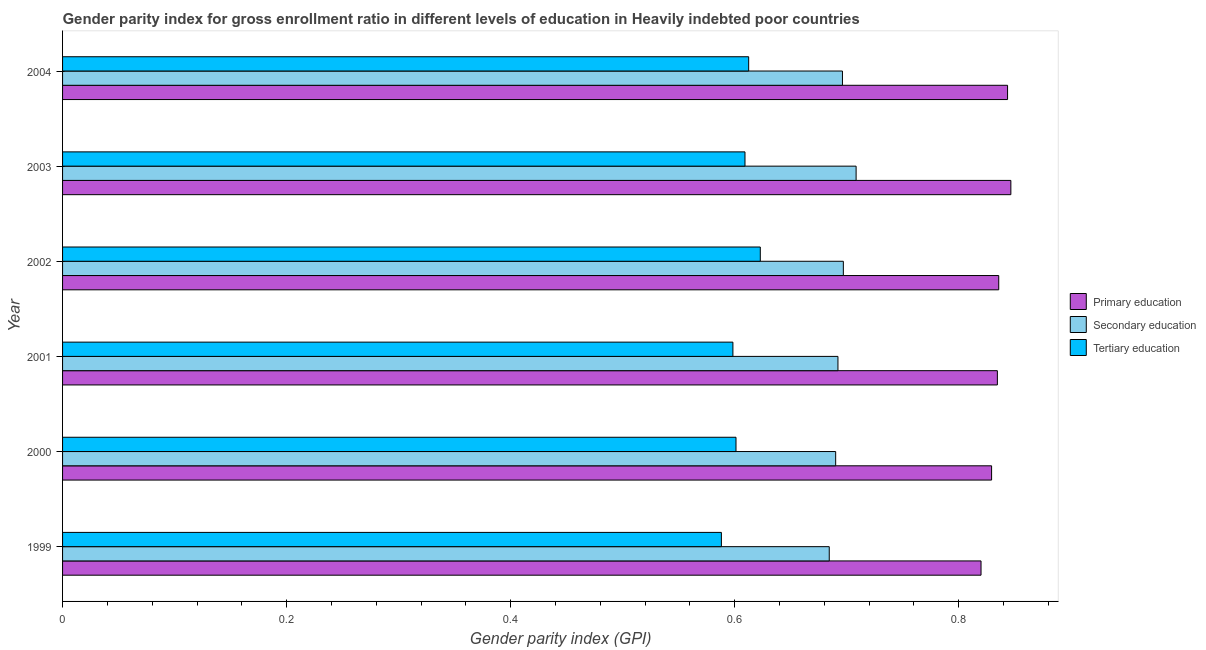How many groups of bars are there?
Offer a terse response. 6. Are the number of bars per tick equal to the number of legend labels?
Make the answer very short. Yes. How many bars are there on the 3rd tick from the bottom?
Provide a succinct answer. 3. What is the label of the 5th group of bars from the top?
Ensure brevity in your answer.  2000. What is the gender parity index in primary education in 2001?
Ensure brevity in your answer.  0.83. Across all years, what is the maximum gender parity index in primary education?
Your answer should be very brief. 0.85. Across all years, what is the minimum gender parity index in secondary education?
Provide a short and direct response. 0.68. In which year was the gender parity index in tertiary education maximum?
Give a very brief answer. 2002. What is the total gender parity index in secondary education in the graph?
Keep it short and to the point. 4.17. What is the difference between the gender parity index in tertiary education in 2000 and that in 2004?
Your response must be concise. -0.01. What is the difference between the gender parity index in tertiary education in 2002 and the gender parity index in primary education in 2003?
Provide a short and direct response. -0.22. What is the average gender parity index in secondary education per year?
Your response must be concise. 0.69. In the year 2003, what is the difference between the gender parity index in primary education and gender parity index in tertiary education?
Your answer should be very brief. 0.24. What is the ratio of the gender parity index in primary education in 2000 to that in 2001?
Your answer should be very brief. 0.99. What does the 2nd bar from the top in 2000 represents?
Your response must be concise. Secondary education. What does the 3rd bar from the bottom in 2001 represents?
Offer a terse response. Tertiary education. Are all the bars in the graph horizontal?
Your response must be concise. Yes. How many years are there in the graph?
Provide a short and direct response. 6. What is the difference between two consecutive major ticks on the X-axis?
Provide a succinct answer. 0.2. Are the values on the major ticks of X-axis written in scientific E-notation?
Ensure brevity in your answer.  No. Where does the legend appear in the graph?
Make the answer very short. Center right. How are the legend labels stacked?
Make the answer very short. Vertical. What is the title of the graph?
Provide a short and direct response. Gender parity index for gross enrollment ratio in different levels of education in Heavily indebted poor countries. What is the label or title of the X-axis?
Your answer should be compact. Gender parity index (GPI). What is the Gender parity index (GPI) of Primary education in 1999?
Provide a succinct answer. 0.82. What is the Gender parity index (GPI) in Secondary education in 1999?
Offer a terse response. 0.68. What is the Gender parity index (GPI) of Tertiary education in 1999?
Your answer should be compact. 0.59. What is the Gender parity index (GPI) in Primary education in 2000?
Give a very brief answer. 0.83. What is the Gender parity index (GPI) in Secondary education in 2000?
Your answer should be very brief. 0.69. What is the Gender parity index (GPI) of Tertiary education in 2000?
Make the answer very short. 0.6. What is the Gender parity index (GPI) in Primary education in 2001?
Provide a succinct answer. 0.83. What is the Gender parity index (GPI) in Secondary education in 2001?
Provide a short and direct response. 0.69. What is the Gender parity index (GPI) of Tertiary education in 2001?
Your answer should be compact. 0.6. What is the Gender parity index (GPI) in Primary education in 2002?
Your answer should be very brief. 0.84. What is the Gender parity index (GPI) in Secondary education in 2002?
Your answer should be compact. 0.7. What is the Gender parity index (GPI) in Tertiary education in 2002?
Your response must be concise. 0.62. What is the Gender parity index (GPI) of Primary education in 2003?
Your answer should be compact. 0.85. What is the Gender parity index (GPI) of Secondary education in 2003?
Provide a short and direct response. 0.71. What is the Gender parity index (GPI) in Tertiary education in 2003?
Keep it short and to the point. 0.61. What is the Gender parity index (GPI) of Primary education in 2004?
Your answer should be compact. 0.84. What is the Gender parity index (GPI) in Secondary education in 2004?
Your answer should be compact. 0.7. What is the Gender parity index (GPI) in Tertiary education in 2004?
Your answer should be compact. 0.61. Across all years, what is the maximum Gender parity index (GPI) of Primary education?
Your response must be concise. 0.85. Across all years, what is the maximum Gender parity index (GPI) in Secondary education?
Keep it short and to the point. 0.71. Across all years, what is the maximum Gender parity index (GPI) of Tertiary education?
Provide a succinct answer. 0.62. Across all years, what is the minimum Gender parity index (GPI) in Primary education?
Ensure brevity in your answer.  0.82. Across all years, what is the minimum Gender parity index (GPI) in Secondary education?
Provide a succinct answer. 0.68. Across all years, what is the minimum Gender parity index (GPI) of Tertiary education?
Provide a succinct answer. 0.59. What is the total Gender parity index (GPI) of Primary education in the graph?
Your answer should be very brief. 5.01. What is the total Gender parity index (GPI) in Secondary education in the graph?
Keep it short and to the point. 4.17. What is the total Gender parity index (GPI) of Tertiary education in the graph?
Your answer should be very brief. 3.63. What is the difference between the Gender parity index (GPI) of Primary education in 1999 and that in 2000?
Your answer should be compact. -0.01. What is the difference between the Gender parity index (GPI) in Secondary education in 1999 and that in 2000?
Offer a very short reply. -0.01. What is the difference between the Gender parity index (GPI) of Tertiary education in 1999 and that in 2000?
Keep it short and to the point. -0.01. What is the difference between the Gender parity index (GPI) of Primary education in 1999 and that in 2001?
Offer a very short reply. -0.01. What is the difference between the Gender parity index (GPI) of Secondary education in 1999 and that in 2001?
Provide a short and direct response. -0.01. What is the difference between the Gender parity index (GPI) in Tertiary education in 1999 and that in 2001?
Keep it short and to the point. -0.01. What is the difference between the Gender parity index (GPI) of Primary education in 1999 and that in 2002?
Make the answer very short. -0.02. What is the difference between the Gender parity index (GPI) of Secondary education in 1999 and that in 2002?
Offer a terse response. -0.01. What is the difference between the Gender parity index (GPI) in Tertiary education in 1999 and that in 2002?
Keep it short and to the point. -0.03. What is the difference between the Gender parity index (GPI) in Primary education in 1999 and that in 2003?
Provide a succinct answer. -0.03. What is the difference between the Gender parity index (GPI) in Secondary education in 1999 and that in 2003?
Provide a short and direct response. -0.02. What is the difference between the Gender parity index (GPI) of Tertiary education in 1999 and that in 2003?
Keep it short and to the point. -0.02. What is the difference between the Gender parity index (GPI) in Primary education in 1999 and that in 2004?
Ensure brevity in your answer.  -0.02. What is the difference between the Gender parity index (GPI) in Secondary education in 1999 and that in 2004?
Your answer should be very brief. -0.01. What is the difference between the Gender parity index (GPI) in Tertiary education in 1999 and that in 2004?
Offer a terse response. -0.02. What is the difference between the Gender parity index (GPI) in Primary education in 2000 and that in 2001?
Keep it short and to the point. -0.01. What is the difference between the Gender parity index (GPI) in Secondary education in 2000 and that in 2001?
Offer a terse response. -0. What is the difference between the Gender parity index (GPI) of Tertiary education in 2000 and that in 2001?
Give a very brief answer. 0. What is the difference between the Gender parity index (GPI) in Primary education in 2000 and that in 2002?
Provide a succinct answer. -0.01. What is the difference between the Gender parity index (GPI) in Secondary education in 2000 and that in 2002?
Give a very brief answer. -0.01. What is the difference between the Gender parity index (GPI) in Tertiary education in 2000 and that in 2002?
Ensure brevity in your answer.  -0.02. What is the difference between the Gender parity index (GPI) of Primary education in 2000 and that in 2003?
Your response must be concise. -0.02. What is the difference between the Gender parity index (GPI) of Secondary education in 2000 and that in 2003?
Offer a very short reply. -0.02. What is the difference between the Gender parity index (GPI) in Tertiary education in 2000 and that in 2003?
Provide a short and direct response. -0.01. What is the difference between the Gender parity index (GPI) of Primary education in 2000 and that in 2004?
Keep it short and to the point. -0.01. What is the difference between the Gender parity index (GPI) of Secondary education in 2000 and that in 2004?
Offer a terse response. -0.01. What is the difference between the Gender parity index (GPI) of Tertiary education in 2000 and that in 2004?
Ensure brevity in your answer.  -0.01. What is the difference between the Gender parity index (GPI) of Primary education in 2001 and that in 2002?
Your answer should be compact. -0. What is the difference between the Gender parity index (GPI) of Secondary education in 2001 and that in 2002?
Ensure brevity in your answer.  -0. What is the difference between the Gender parity index (GPI) of Tertiary education in 2001 and that in 2002?
Ensure brevity in your answer.  -0.02. What is the difference between the Gender parity index (GPI) of Primary education in 2001 and that in 2003?
Offer a very short reply. -0.01. What is the difference between the Gender parity index (GPI) in Secondary education in 2001 and that in 2003?
Make the answer very short. -0.02. What is the difference between the Gender parity index (GPI) of Tertiary education in 2001 and that in 2003?
Your answer should be compact. -0.01. What is the difference between the Gender parity index (GPI) of Primary education in 2001 and that in 2004?
Your answer should be very brief. -0.01. What is the difference between the Gender parity index (GPI) of Secondary education in 2001 and that in 2004?
Give a very brief answer. -0. What is the difference between the Gender parity index (GPI) in Tertiary education in 2001 and that in 2004?
Offer a very short reply. -0.01. What is the difference between the Gender parity index (GPI) of Primary education in 2002 and that in 2003?
Make the answer very short. -0.01. What is the difference between the Gender parity index (GPI) in Secondary education in 2002 and that in 2003?
Provide a short and direct response. -0.01. What is the difference between the Gender parity index (GPI) in Tertiary education in 2002 and that in 2003?
Provide a succinct answer. 0.01. What is the difference between the Gender parity index (GPI) in Primary education in 2002 and that in 2004?
Give a very brief answer. -0.01. What is the difference between the Gender parity index (GPI) in Secondary education in 2002 and that in 2004?
Ensure brevity in your answer.  0. What is the difference between the Gender parity index (GPI) in Tertiary education in 2002 and that in 2004?
Your answer should be compact. 0.01. What is the difference between the Gender parity index (GPI) in Primary education in 2003 and that in 2004?
Offer a very short reply. 0. What is the difference between the Gender parity index (GPI) of Secondary education in 2003 and that in 2004?
Provide a short and direct response. 0.01. What is the difference between the Gender parity index (GPI) of Tertiary education in 2003 and that in 2004?
Provide a succinct answer. -0. What is the difference between the Gender parity index (GPI) in Primary education in 1999 and the Gender parity index (GPI) in Secondary education in 2000?
Offer a very short reply. 0.13. What is the difference between the Gender parity index (GPI) in Primary education in 1999 and the Gender parity index (GPI) in Tertiary education in 2000?
Provide a short and direct response. 0.22. What is the difference between the Gender parity index (GPI) in Secondary education in 1999 and the Gender parity index (GPI) in Tertiary education in 2000?
Offer a terse response. 0.08. What is the difference between the Gender parity index (GPI) of Primary education in 1999 and the Gender parity index (GPI) of Secondary education in 2001?
Provide a short and direct response. 0.13. What is the difference between the Gender parity index (GPI) of Primary education in 1999 and the Gender parity index (GPI) of Tertiary education in 2001?
Your answer should be very brief. 0.22. What is the difference between the Gender parity index (GPI) in Secondary education in 1999 and the Gender parity index (GPI) in Tertiary education in 2001?
Offer a very short reply. 0.09. What is the difference between the Gender parity index (GPI) of Primary education in 1999 and the Gender parity index (GPI) of Secondary education in 2002?
Make the answer very short. 0.12. What is the difference between the Gender parity index (GPI) in Primary education in 1999 and the Gender parity index (GPI) in Tertiary education in 2002?
Your answer should be very brief. 0.2. What is the difference between the Gender parity index (GPI) of Secondary education in 1999 and the Gender parity index (GPI) of Tertiary education in 2002?
Ensure brevity in your answer.  0.06. What is the difference between the Gender parity index (GPI) in Primary education in 1999 and the Gender parity index (GPI) in Secondary education in 2003?
Give a very brief answer. 0.11. What is the difference between the Gender parity index (GPI) of Primary education in 1999 and the Gender parity index (GPI) of Tertiary education in 2003?
Provide a short and direct response. 0.21. What is the difference between the Gender parity index (GPI) in Secondary education in 1999 and the Gender parity index (GPI) in Tertiary education in 2003?
Your answer should be compact. 0.08. What is the difference between the Gender parity index (GPI) in Primary education in 1999 and the Gender parity index (GPI) in Secondary education in 2004?
Offer a terse response. 0.12. What is the difference between the Gender parity index (GPI) of Primary education in 1999 and the Gender parity index (GPI) of Tertiary education in 2004?
Your answer should be compact. 0.21. What is the difference between the Gender parity index (GPI) of Secondary education in 1999 and the Gender parity index (GPI) of Tertiary education in 2004?
Offer a terse response. 0.07. What is the difference between the Gender parity index (GPI) of Primary education in 2000 and the Gender parity index (GPI) of Secondary education in 2001?
Keep it short and to the point. 0.14. What is the difference between the Gender parity index (GPI) of Primary education in 2000 and the Gender parity index (GPI) of Tertiary education in 2001?
Offer a very short reply. 0.23. What is the difference between the Gender parity index (GPI) in Secondary education in 2000 and the Gender parity index (GPI) in Tertiary education in 2001?
Your answer should be very brief. 0.09. What is the difference between the Gender parity index (GPI) of Primary education in 2000 and the Gender parity index (GPI) of Secondary education in 2002?
Your response must be concise. 0.13. What is the difference between the Gender parity index (GPI) in Primary education in 2000 and the Gender parity index (GPI) in Tertiary education in 2002?
Keep it short and to the point. 0.21. What is the difference between the Gender parity index (GPI) in Secondary education in 2000 and the Gender parity index (GPI) in Tertiary education in 2002?
Make the answer very short. 0.07. What is the difference between the Gender parity index (GPI) in Primary education in 2000 and the Gender parity index (GPI) in Secondary education in 2003?
Offer a terse response. 0.12. What is the difference between the Gender parity index (GPI) of Primary education in 2000 and the Gender parity index (GPI) of Tertiary education in 2003?
Provide a succinct answer. 0.22. What is the difference between the Gender parity index (GPI) in Secondary education in 2000 and the Gender parity index (GPI) in Tertiary education in 2003?
Your response must be concise. 0.08. What is the difference between the Gender parity index (GPI) of Primary education in 2000 and the Gender parity index (GPI) of Secondary education in 2004?
Your response must be concise. 0.13. What is the difference between the Gender parity index (GPI) in Primary education in 2000 and the Gender parity index (GPI) in Tertiary education in 2004?
Provide a short and direct response. 0.22. What is the difference between the Gender parity index (GPI) in Secondary education in 2000 and the Gender parity index (GPI) in Tertiary education in 2004?
Offer a very short reply. 0.08. What is the difference between the Gender parity index (GPI) of Primary education in 2001 and the Gender parity index (GPI) of Secondary education in 2002?
Your answer should be compact. 0.14. What is the difference between the Gender parity index (GPI) of Primary education in 2001 and the Gender parity index (GPI) of Tertiary education in 2002?
Offer a terse response. 0.21. What is the difference between the Gender parity index (GPI) of Secondary education in 2001 and the Gender parity index (GPI) of Tertiary education in 2002?
Your answer should be compact. 0.07. What is the difference between the Gender parity index (GPI) in Primary education in 2001 and the Gender parity index (GPI) in Secondary education in 2003?
Offer a very short reply. 0.13. What is the difference between the Gender parity index (GPI) in Primary education in 2001 and the Gender parity index (GPI) in Tertiary education in 2003?
Give a very brief answer. 0.23. What is the difference between the Gender parity index (GPI) of Secondary education in 2001 and the Gender parity index (GPI) of Tertiary education in 2003?
Make the answer very short. 0.08. What is the difference between the Gender parity index (GPI) in Primary education in 2001 and the Gender parity index (GPI) in Secondary education in 2004?
Keep it short and to the point. 0.14. What is the difference between the Gender parity index (GPI) of Primary education in 2001 and the Gender parity index (GPI) of Tertiary education in 2004?
Keep it short and to the point. 0.22. What is the difference between the Gender parity index (GPI) of Secondary education in 2001 and the Gender parity index (GPI) of Tertiary education in 2004?
Your answer should be very brief. 0.08. What is the difference between the Gender parity index (GPI) of Primary education in 2002 and the Gender parity index (GPI) of Secondary education in 2003?
Offer a terse response. 0.13. What is the difference between the Gender parity index (GPI) in Primary education in 2002 and the Gender parity index (GPI) in Tertiary education in 2003?
Offer a terse response. 0.23. What is the difference between the Gender parity index (GPI) of Secondary education in 2002 and the Gender parity index (GPI) of Tertiary education in 2003?
Your answer should be very brief. 0.09. What is the difference between the Gender parity index (GPI) in Primary education in 2002 and the Gender parity index (GPI) in Secondary education in 2004?
Offer a very short reply. 0.14. What is the difference between the Gender parity index (GPI) of Primary education in 2002 and the Gender parity index (GPI) of Tertiary education in 2004?
Make the answer very short. 0.22. What is the difference between the Gender parity index (GPI) in Secondary education in 2002 and the Gender parity index (GPI) in Tertiary education in 2004?
Offer a terse response. 0.08. What is the difference between the Gender parity index (GPI) in Primary education in 2003 and the Gender parity index (GPI) in Secondary education in 2004?
Keep it short and to the point. 0.15. What is the difference between the Gender parity index (GPI) of Primary education in 2003 and the Gender parity index (GPI) of Tertiary education in 2004?
Provide a short and direct response. 0.23. What is the difference between the Gender parity index (GPI) of Secondary education in 2003 and the Gender parity index (GPI) of Tertiary education in 2004?
Provide a succinct answer. 0.1. What is the average Gender parity index (GPI) in Primary education per year?
Your response must be concise. 0.83. What is the average Gender parity index (GPI) of Secondary education per year?
Make the answer very short. 0.69. What is the average Gender parity index (GPI) in Tertiary education per year?
Provide a succinct answer. 0.61. In the year 1999, what is the difference between the Gender parity index (GPI) in Primary education and Gender parity index (GPI) in Secondary education?
Keep it short and to the point. 0.14. In the year 1999, what is the difference between the Gender parity index (GPI) in Primary education and Gender parity index (GPI) in Tertiary education?
Provide a succinct answer. 0.23. In the year 1999, what is the difference between the Gender parity index (GPI) in Secondary education and Gender parity index (GPI) in Tertiary education?
Your answer should be compact. 0.1. In the year 2000, what is the difference between the Gender parity index (GPI) in Primary education and Gender parity index (GPI) in Secondary education?
Ensure brevity in your answer.  0.14. In the year 2000, what is the difference between the Gender parity index (GPI) in Primary education and Gender parity index (GPI) in Tertiary education?
Keep it short and to the point. 0.23. In the year 2000, what is the difference between the Gender parity index (GPI) in Secondary education and Gender parity index (GPI) in Tertiary education?
Make the answer very short. 0.09. In the year 2001, what is the difference between the Gender parity index (GPI) of Primary education and Gender parity index (GPI) of Secondary education?
Your answer should be compact. 0.14. In the year 2001, what is the difference between the Gender parity index (GPI) of Primary education and Gender parity index (GPI) of Tertiary education?
Provide a succinct answer. 0.24. In the year 2001, what is the difference between the Gender parity index (GPI) in Secondary education and Gender parity index (GPI) in Tertiary education?
Offer a very short reply. 0.09. In the year 2002, what is the difference between the Gender parity index (GPI) in Primary education and Gender parity index (GPI) in Secondary education?
Give a very brief answer. 0.14. In the year 2002, what is the difference between the Gender parity index (GPI) in Primary education and Gender parity index (GPI) in Tertiary education?
Ensure brevity in your answer.  0.21. In the year 2002, what is the difference between the Gender parity index (GPI) of Secondary education and Gender parity index (GPI) of Tertiary education?
Provide a short and direct response. 0.07. In the year 2003, what is the difference between the Gender parity index (GPI) of Primary education and Gender parity index (GPI) of Secondary education?
Keep it short and to the point. 0.14. In the year 2003, what is the difference between the Gender parity index (GPI) of Primary education and Gender parity index (GPI) of Tertiary education?
Give a very brief answer. 0.24. In the year 2003, what is the difference between the Gender parity index (GPI) in Secondary education and Gender parity index (GPI) in Tertiary education?
Offer a very short reply. 0.1. In the year 2004, what is the difference between the Gender parity index (GPI) in Primary education and Gender parity index (GPI) in Secondary education?
Your answer should be very brief. 0.15. In the year 2004, what is the difference between the Gender parity index (GPI) of Primary education and Gender parity index (GPI) of Tertiary education?
Your answer should be very brief. 0.23. In the year 2004, what is the difference between the Gender parity index (GPI) in Secondary education and Gender parity index (GPI) in Tertiary education?
Make the answer very short. 0.08. What is the ratio of the Gender parity index (GPI) of Primary education in 1999 to that in 2000?
Your answer should be compact. 0.99. What is the ratio of the Gender parity index (GPI) in Tertiary education in 1999 to that in 2000?
Ensure brevity in your answer.  0.98. What is the ratio of the Gender parity index (GPI) of Primary education in 1999 to that in 2001?
Your answer should be compact. 0.98. What is the ratio of the Gender parity index (GPI) in Tertiary education in 1999 to that in 2001?
Offer a terse response. 0.98. What is the ratio of the Gender parity index (GPI) of Primary education in 1999 to that in 2002?
Your answer should be compact. 0.98. What is the ratio of the Gender parity index (GPI) in Secondary education in 1999 to that in 2002?
Offer a very short reply. 0.98. What is the ratio of the Gender parity index (GPI) of Tertiary education in 1999 to that in 2002?
Your answer should be compact. 0.94. What is the ratio of the Gender parity index (GPI) of Primary education in 1999 to that in 2003?
Offer a very short reply. 0.97. What is the ratio of the Gender parity index (GPI) in Secondary education in 1999 to that in 2003?
Keep it short and to the point. 0.97. What is the ratio of the Gender parity index (GPI) of Tertiary education in 1999 to that in 2003?
Provide a short and direct response. 0.97. What is the ratio of the Gender parity index (GPI) in Primary education in 1999 to that in 2004?
Offer a very short reply. 0.97. What is the ratio of the Gender parity index (GPI) in Secondary education in 1999 to that in 2004?
Your answer should be very brief. 0.98. What is the ratio of the Gender parity index (GPI) of Tertiary education in 1999 to that in 2004?
Make the answer very short. 0.96. What is the ratio of the Gender parity index (GPI) in Primary education in 2000 to that in 2001?
Provide a succinct answer. 0.99. What is the ratio of the Gender parity index (GPI) of Primary education in 2000 to that in 2002?
Your answer should be compact. 0.99. What is the ratio of the Gender parity index (GPI) of Secondary education in 2000 to that in 2002?
Offer a very short reply. 0.99. What is the ratio of the Gender parity index (GPI) of Tertiary education in 2000 to that in 2002?
Ensure brevity in your answer.  0.97. What is the ratio of the Gender parity index (GPI) of Primary education in 2000 to that in 2003?
Provide a succinct answer. 0.98. What is the ratio of the Gender parity index (GPI) in Secondary education in 2000 to that in 2003?
Ensure brevity in your answer.  0.97. What is the ratio of the Gender parity index (GPI) in Tertiary education in 2000 to that in 2003?
Make the answer very short. 0.99. What is the ratio of the Gender parity index (GPI) of Primary education in 2000 to that in 2004?
Offer a very short reply. 0.98. What is the ratio of the Gender parity index (GPI) in Secondary education in 2000 to that in 2004?
Give a very brief answer. 0.99. What is the ratio of the Gender parity index (GPI) of Tertiary education in 2000 to that in 2004?
Your answer should be very brief. 0.98. What is the ratio of the Gender parity index (GPI) of Secondary education in 2001 to that in 2002?
Your answer should be very brief. 0.99. What is the ratio of the Gender parity index (GPI) of Tertiary education in 2001 to that in 2002?
Offer a terse response. 0.96. What is the ratio of the Gender parity index (GPI) of Primary education in 2001 to that in 2003?
Keep it short and to the point. 0.99. What is the ratio of the Gender parity index (GPI) of Secondary education in 2001 to that in 2003?
Offer a very short reply. 0.98. What is the ratio of the Gender parity index (GPI) of Tertiary education in 2001 to that in 2003?
Keep it short and to the point. 0.98. What is the ratio of the Gender parity index (GPI) of Primary education in 2001 to that in 2004?
Ensure brevity in your answer.  0.99. What is the ratio of the Gender parity index (GPI) in Primary education in 2002 to that in 2003?
Your answer should be compact. 0.99. What is the ratio of the Gender parity index (GPI) in Secondary education in 2002 to that in 2003?
Your answer should be very brief. 0.98. What is the ratio of the Gender parity index (GPI) of Tertiary education in 2002 to that in 2003?
Give a very brief answer. 1.02. What is the ratio of the Gender parity index (GPI) in Primary education in 2002 to that in 2004?
Provide a short and direct response. 0.99. What is the ratio of the Gender parity index (GPI) in Tertiary education in 2002 to that in 2004?
Offer a very short reply. 1.02. What is the ratio of the Gender parity index (GPI) in Primary education in 2003 to that in 2004?
Ensure brevity in your answer.  1. What is the ratio of the Gender parity index (GPI) of Secondary education in 2003 to that in 2004?
Offer a terse response. 1.02. What is the ratio of the Gender parity index (GPI) of Tertiary education in 2003 to that in 2004?
Your answer should be very brief. 0.99. What is the difference between the highest and the second highest Gender parity index (GPI) in Primary education?
Keep it short and to the point. 0. What is the difference between the highest and the second highest Gender parity index (GPI) of Secondary education?
Give a very brief answer. 0.01. What is the difference between the highest and the second highest Gender parity index (GPI) in Tertiary education?
Give a very brief answer. 0.01. What is the difference between the highest and the lowest Gender parity index (GPI) of Primary education?
Your response must be concise. 0.03. What is the difference between the highest and the lowest Gender parity index (GPI) of Secondary education?
Provide a succinct answer. 0.02. What is the difference between the highest and the lowest Gender parity index (GPI) in Tertiary education?
Provide a short and direct response. 0.03. 